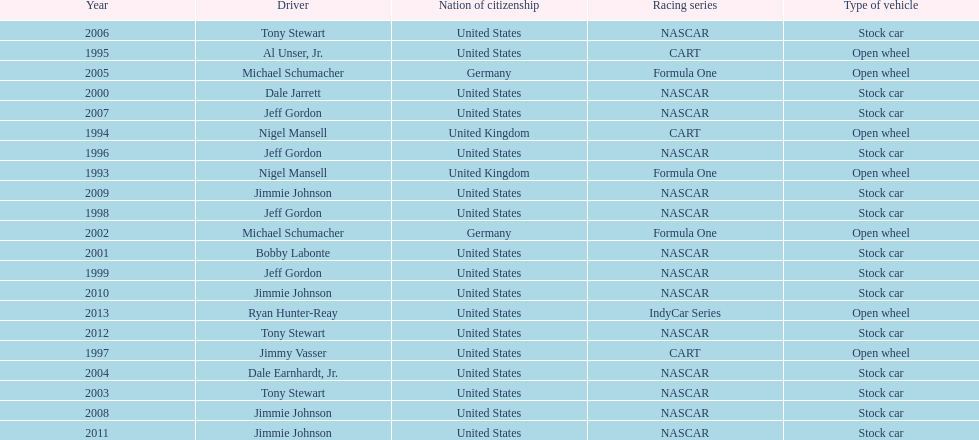Could you parse the entire table as a dict? {'header': ['Year', 'Driver', 'Nation of citizenship', 'Racing series', 'Type of vehicle'], 'rows': [['2006', 'Tony Stewart', 'United States', 'NASCAR', 'Stock car'], ['1995', 'Al Unser, Jr.', 'United States', 'CART', 'Open wheel'], ['2005', 'Michael Schumacher', 'Germany', 'Formula One', 'Open wheel'], ['2000', 'Dale Jarrett', 'United States', 'NASCAR', 'Stock car'], ['2007', 'Jeff Gordon', 'United States', 'NASCAR', 'Stock car'], ['1994', 'Nigel Mansell', 'United Kingdom', 'CART', 'Open wheel'], ['1996', 'Jeff Gordon', 'United States', 'NASCAR', 'Stock car'], ['1993', 'Nigel Mansell', 'United Kingdom', 'Formula One', 'Open wheel'], ['2009', 'Jimmie Johnson', 'United States', 'NASCAR', 'Stock car'], ['1998', 'Jeff Gordon', 'United States', 'NASCAR', 'Stock car'], ['2002', 'Michael Schumacher', 'Germany', 'Formula One', 'Open wheel'], ['2001', 'Bobby Labonte', 'United States', 'NASCAR', 'Stock car'], ['1999', 'Jeff Gordon', 'United States', 'NASCAR', 'Stock car'], ['2010', 'Jimmie Johnson', 'United States', 'NASCAR', 'Stock car'], ['2013', 'Ryan Hunter-Reay', 'United States', 'IndyCar Series', 'Open wheel'], ['2012', 'Tony Stewart', 'United States', 'NASCAR', 'Stock car'], ['1997', 'Jimmy Vasser', 'United States', 'CART', 'Open wheel'], ['2004', 'Dale Earnhardt, Jr.', 'United States', 'NASCAR', 'Stock car'], ['2003', 'Tony Stewart', 'United States', 'NASCAR', 'Stock car'], ['2008', 'Jimmie Johnson', 'United States', 'NASCAR', 'Stock car'], ['2011', 'Jimmie Johnson', 'United States', 'NASCAR', 'Stock car']]} Which driver had four consecutive wins? Jimmie Johnson. 